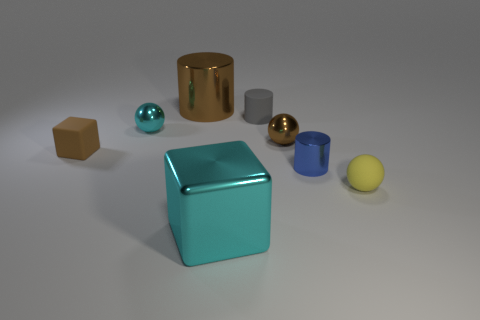Subtract all small shiny spheres. How many spheres are left? 1 Add 1 balls. How many objects exist? 9 Subtract all brown spheres. How many spheres are left? 2 Subtract all cubes. How many objects are left? 6 Subtract 1 yellow spheres. How many objects are left? 7 Subtract 1 cylinders. How many cylinders are left? 2 Subtract all brown balls. Subtract all blue cylinders. How many balls are left? 2 Subtract all tiny yellow spheres. Subtract all big purple things. How many objects are left? 7 Add 2 cylinders. How many cylinders are left? 5 Add 1 small brown rubber cubes. How many small brown rubber cubes exist? 2 